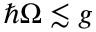<formula> <loc_0><loc_0><loc_500><loc_500>\hbar { \Omega } \lesssim g</formula> 